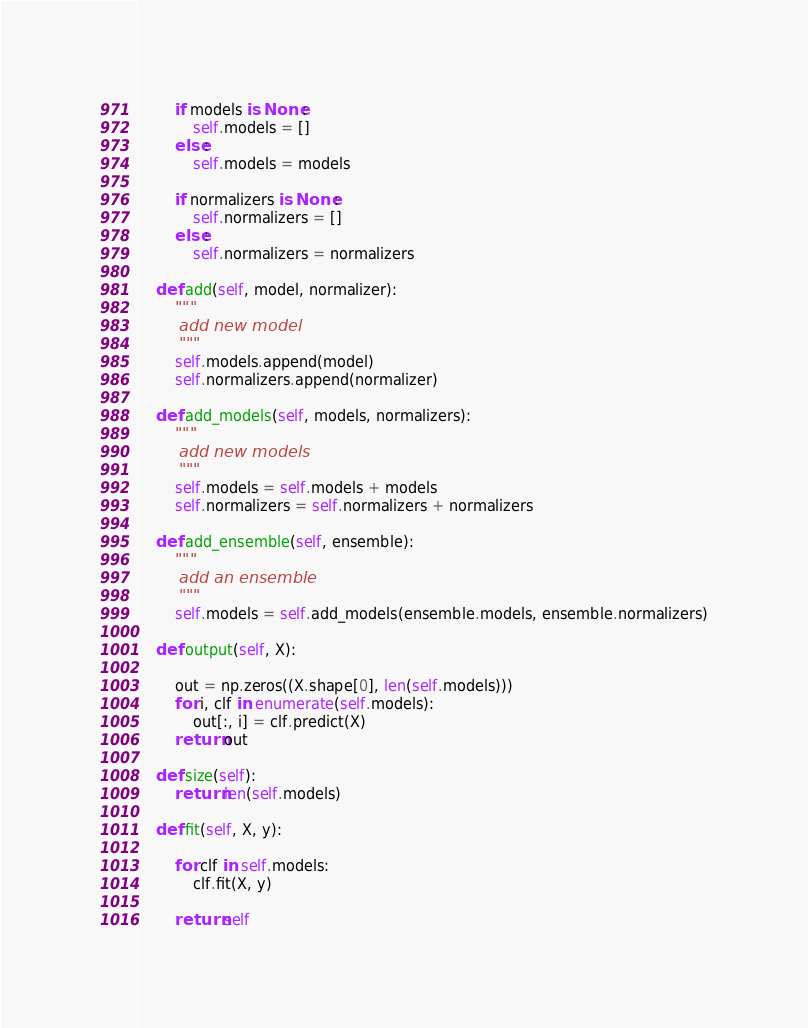Convert code to text. <code><loc_0><loc_0><loc_500><loc_500><_Python_>
        if models is None:
            self.models = []
        else:
            self.models = models

        if normalizers is None:
            self.normalizers = []
        else:
            self.normalizers = normalizers

    def add(self, model, normalizer):
        """
        add new model
        """
        self.models.append(model)
        self.normalizers.append(normalizer)

    def add_models(self, models, normalizers):
        """
        add new models
        """
        self.models = self.models + models
        self.normalizers = self.normalizers + normalizers

    def add_ensemble(self, ensemble):
        """
        add an ensemble
        """
        self.models = self.add_models(ensemble.models, ensemble.normalizers)

    def output(self, X):

        out = np.zeros((X.shape[0], len(self.models)))
        for i, clf in enumerate(self.models):
            out[:, i] = clf.predict(X)
        return out

    def size(self):
        return len(self.models)

    def fit(self, X, y):

        for clf in self.models:
            clf.fit(X, y)

        return self
</code> 